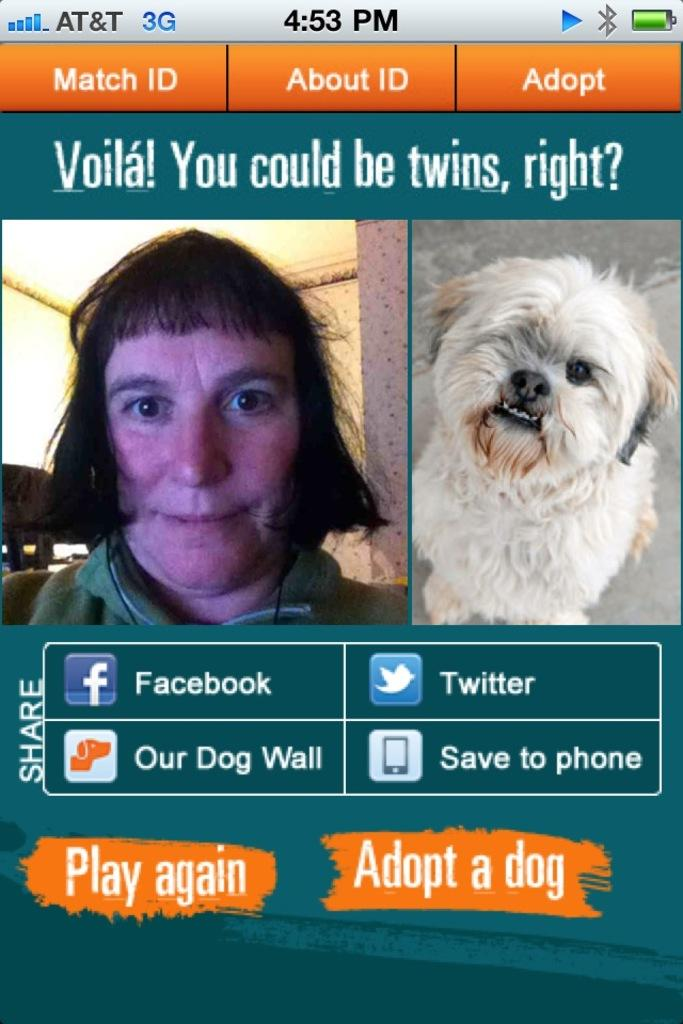What is the main object in the image? There is a screen in the image. What can be seen on the screen? A person and a dog are visible on the screen. Are there any additional elements on the screen? Yes, there are symbols and text on the screen. Can you see any farm animals on the screen? There are no farm animals visible on the screen; it features a person and a dog. How does the ant show respect on the screen? There is no ant present on the screen, so it cannot show respect. 